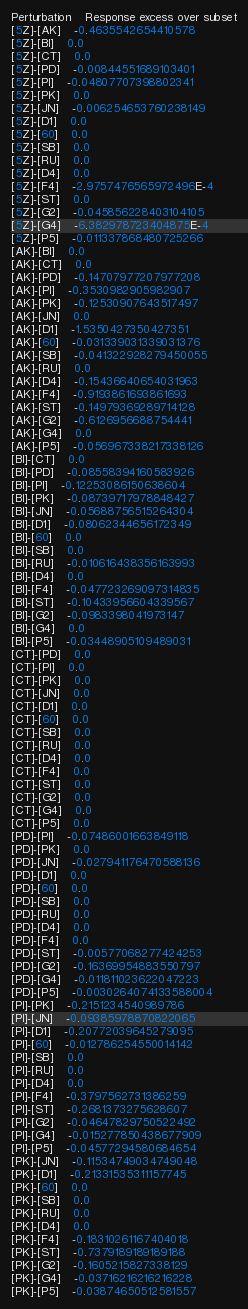Convert code to text. <code><loc_0><loc_0><loc_500><loc_500><_SQL_>Perturbation	Response excess over subset
[5Z]-[AK]	-0.4635542654410578
[5Z]-[BI]	0.0
[5Z]-[CT]	0.0
[5Z]-[PD]	-0.00844551689103401
[5Z]-[PI]	-0.04807707398802341
[5Z]-[PK]	0.0
[5Z]-[JN]	-0.006254653760238149
[5Z]-[D1]	0.0
[5Z]-[60]	0.0
[5Z]-[SB]	0.0
[5Z]-[RU]	0.0
[5Z]-[D4]	0.0
[5Z]-[F4]	-2.9757476565972496E-4
[5Z]-[ST]	0.0
[5Z]-[G2]	-0.045856228403104105
[5Z]-[G4]	-6.382978723404875E-4
[5Z]-[P5]	-0.011337868480725266
[AK]-[BI]	0.0
[AK]-[CT]	0.0
[AK]-[PD]	-0.14707977207977208
[AK]-[PI]	-0.3530982905982907
[AK]-[PK]	-0.12530907643517497
[AK]-[JN]	0.0
[AK]-[D1]	-1.5350427350427351
[AK]-[60]	-0.031339031339031376
[AK]-[SB]	-0.041322928279450055
[AK]-[RU]	0.0
[AK]-[D4]	-0.15436640654031963
[AK]-[F4]	-0.9193861693861693
[AK]-[ST]	-0.14979369289714128
[AK]-[G2]	-0.6126956688754441
[AK]-[G4]	0.0
[AK]-[P5]	-0.056967338217338126
[BI]-[CT]	0.0
[BI]-[PD]	-0.08558394160583926
[BI]-[PI]	-0.12253086150638604
[BI]-[PK]	-0.08739717978848427
[BI]-[JN]	-0.05688756515264304
[BI]-[D1]	-0.08062344656172349
[BI]-[60]	0.0
[BI]-[SB]	0.0
[BI]-[RU]	-0.010616438356163993
[BI]-[D4]	0.0
[BI]-[F4]	-0.047723269097314835
[BI]-[ST]	-0.10433956604339567
[BI]-[G2]	-0.0983398041973147
[BI]-[G4]	0.0
[BI]-[P5]	-0.03448905109489031
[CT]-[PD]	0.0
[CT]-[PI]	0.0
[CT]-[PK]	0.0
[CT]-[JN]	0.0
[CT]-[D1]	0.0
[CT]-[60]	0.0
[CT]-[SB]	0.0
[CT]-[RU]	0.0
[CT]-[D4]	0.0
[CT]-[F4]	0.0
[CT]-[ST]	0.0
[CT]-[G2]	0.0
[CT]-[G4]	0.0
[CT]-[P5]	0.0
[PD]-[PI]	-0.07486001663849118
[PD]-[PK]	0.0
[PD]-[JN]	-0.027941176470588136
[PD]-[D1]	0.0
[PD]-[60]	0.0
[PD]-[SB]	0.0
[PD]-[RU]	0.0
[PD]-[D4]	0.0
[PD]-[F4]	0.0
[PD]-[ST]	-0.00577068277424253
[PD]-[G2]	-0.16369954883550797
[PD]-[G4]	-0.011811023622047223
[PD]-[P5]	-0.0030264074133588004
[PI]-[PK]	-0.2151234540989786
[PI]-[JN]	-0.09385978870822065
[PI]-[D1]	-0.20772039645279095
[PI]-[60]	-0.012786254550014142
[PI]-[SB]	0.0
[PI]-[RU]	0.0
[PI]-[D4]	0.0
[PI]-[F4]	-0.3797562731386259
[PI]-[ST]	-0.2681373275628607
[PI]-[G2]	-0.04647829750522492
[PI]-[G4]	-0.015277850438677909
[PI]-[P5]	-0.04577294580684654
[PK]-[JN]	-0.11534749034749048
[PK]-[D1]	-0.21331535311157745
[PK]-[60]	0.0
[PK]-[SB]	0.0
[PK]-[RU]	0.0
[PK]-[D4]	0.0
[PK]-[F4]	-0.18310261167404018
[PK]-[ST]	-0.7379189189189188
[PK]-[G2]	-0.1605215827338129
[PK]-[G4]	-0.03716216216216228
[PK]-[P5]	-0.03874650512581557</code> 